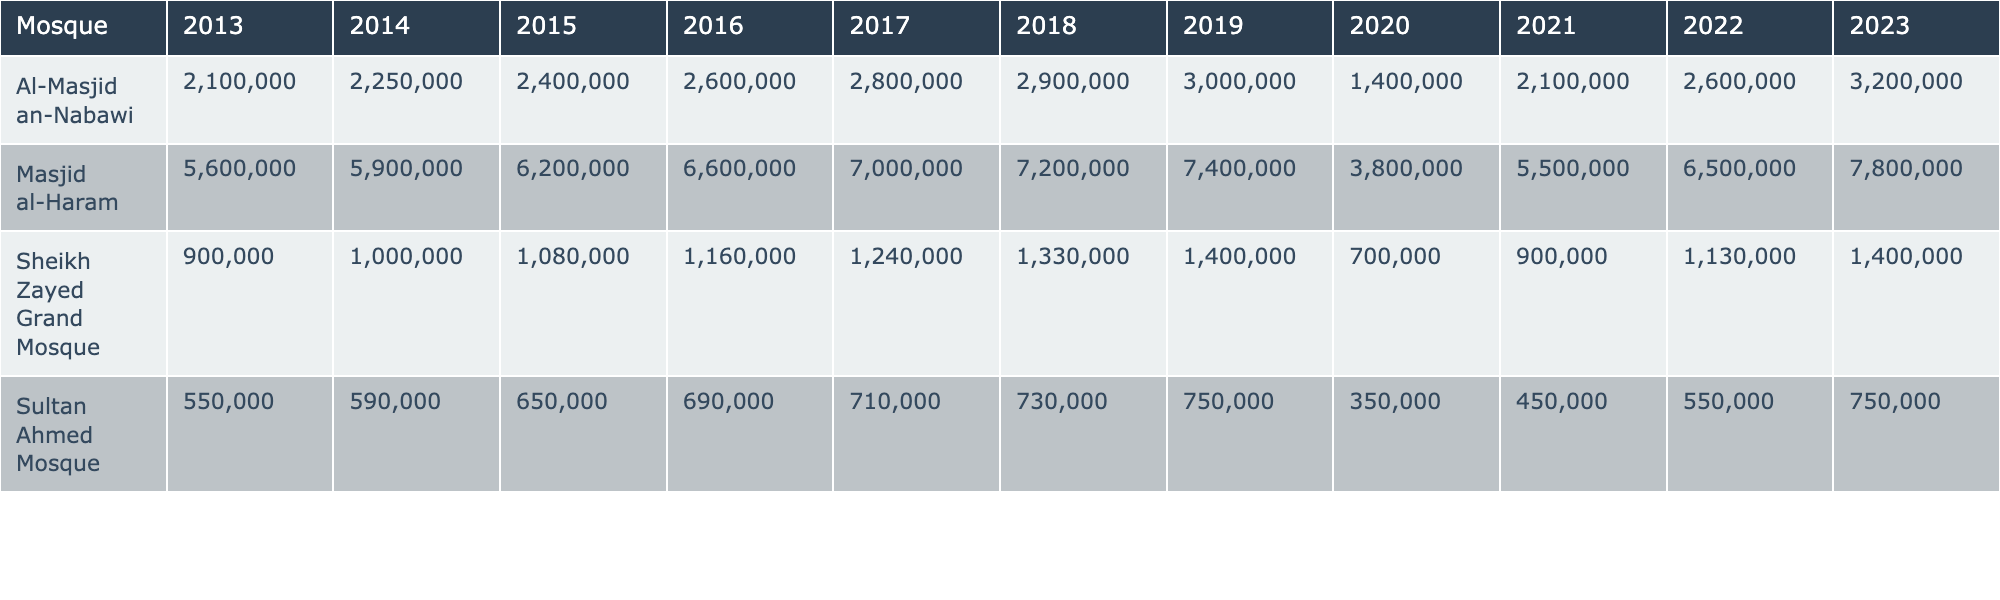What's the total number of visitors to Al-Masjid an-Nabawi in 2022? In the table, under the column for "Al-Masjid an-Nabawi" and the year 2022, the total number of visitors is listed as 2,600,000.
Answer: 2,600,000 Which mosque had the highest number of visitors in 2023? Looking at the column for 2023, "Masjid al-Haram" has the highest total visitors listed at 7,800,000, compared to other mosques in the same year.
Answer: Masjid al-Haram What is the difference in total visitors between Sheikh Zayed Grand Mosque in 2019 and 2023? In 2019, Sheikh Zayed Grand Mosque had 1,400,000 visitors, and in 2023 it had 1,400,000 visitors as well. Therefore, the difference is 1,400,000 - 1,400,000 = 0.
Answer: 0 How many total visitors did Sultan Ahmed Mosque receive in 2020? The table shows that Sultan Ahmed Mosque had a total of 350,000 visitors in 2020.
Answer: 350,000 What is the average number of total visitors to Al-Masjid an-Nabawi from 2013 to 2023? We sum the total visitors for Al-Masjid an-Nabawi from 2013 (2,100,000) to 2023 (3,200,000) which equals 27,100,000. Divided by the 11 years gives an average of 27,100,000 / 11 = 2,463,636.36.
Answer: 2,463,636.36 Did the total number of visitors to the Sheikh Zayed Grand Mosque increase or decrease from 2013 to 2023? In 2013, the total visitors were 900,000 and in 2023 it was 1,400,000. Since 1,400,000 is greater than 900,000, the number has increased.
Answer: Increased What percentage of visitors in 2022 to Masjid al-Haram compared to the total visitors across all mosques, if the total visitors across all mosques in 2022 is 12,300,000? Masjid al-Haram had 6,500,000 visitors in 2022. To find the percentage, we calculate (6,500,000 / 12,300,000) * 100 which equals approximately 52.86%.
Answer: 52.86% Which mosque showed a significant drop in visitors in 2020 compared to 2019? Comparing the numbers, "Al-Masjid an-Nabawi" dropped from 3,000,000 visitors in 2019 to 1,400,000 in 2020, indicating a significant decrease.
Answer: Al-Masjid an-Nabawi What is the total visitor count for all mosques in the year 2021? Summing the total visitors for each mosque in 2021 gives us: Al-Masjid an-Nabawi (2,100,000) + Masjid al-Haram (5,500,000) + Sheikh Zayed Grand Mosque (900,000) + Sultan Ahmed Mosque (450,000) = 9,950,000.
Answer: 9,950,000 Which year had the lowest total visitors across all mosques? By reviewing the total visitors for each year in the table, the year 2020 had the lowest total at 5,950,000 visitors across all mosques.
Answer: 2020 